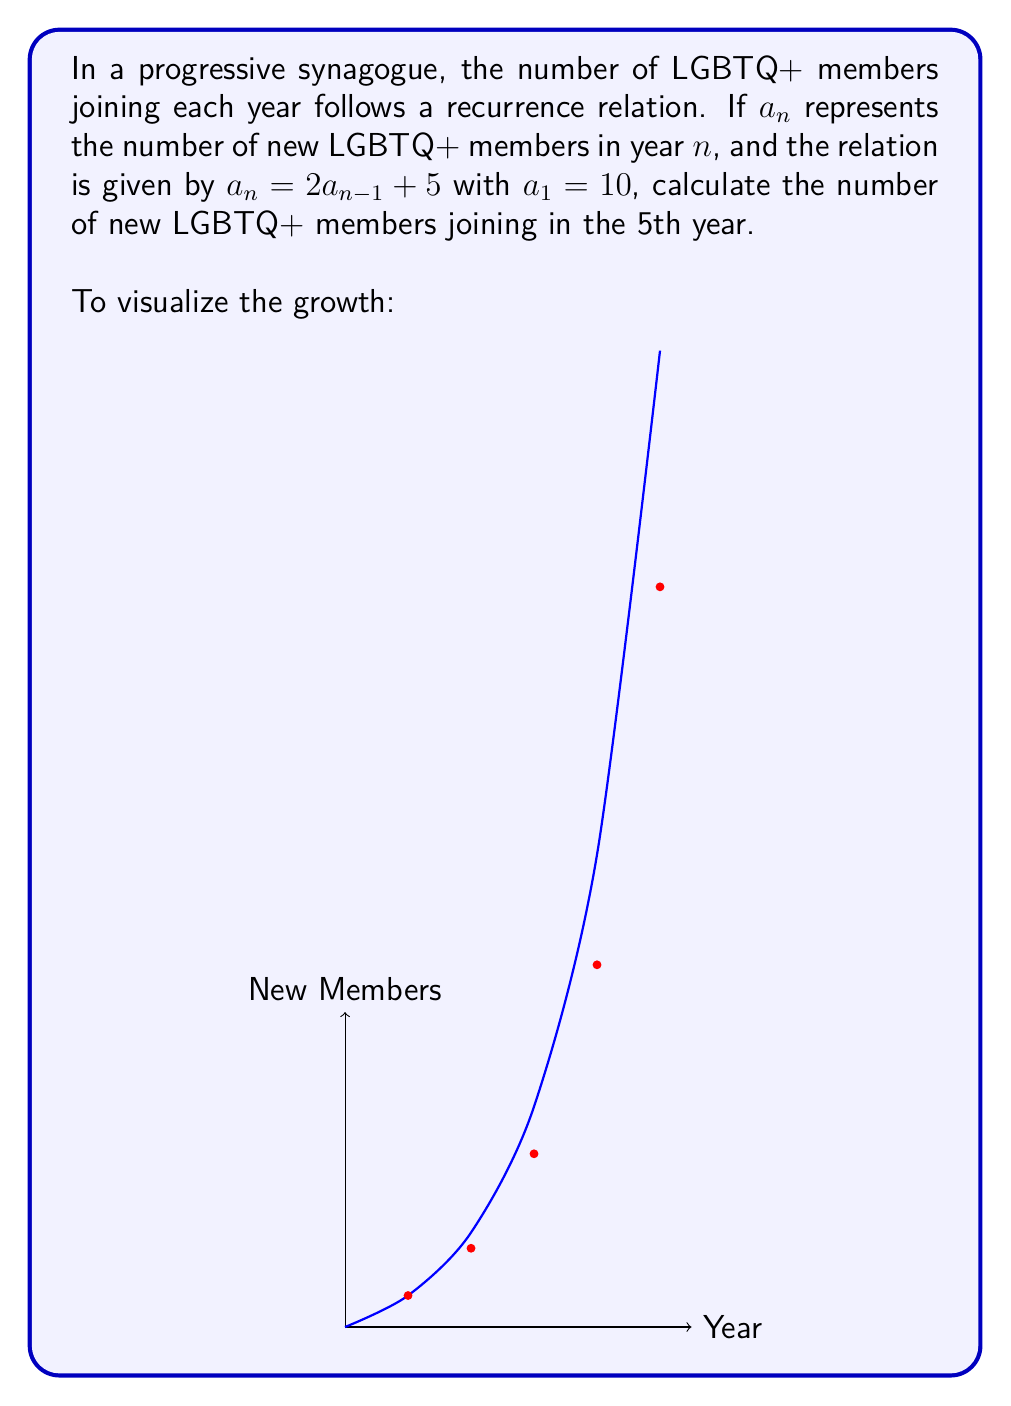What is the answer to this math problem? Let's solve this step-by-step:

1) We're given the recurrence relation: $a_n = 2a_{n-1} + 5$ with $a_1 = 10$

2) Let's calculate the first few terms:
   $a_1 = 10$ (given)
   $a_2 = 2(10) + 5 = 25$
   $a_3 = 2(25) + 5 = 55$
   $a_4 = 2(55) + 5 = 115$

3) For $a_5$, we use the same relation:
   $a_5 = 2a_4 + 5$
   $a_5 = 2(115) + 5$
   $a_5 = 230 + 5 = 235$

4) We can verify this matches the general solution for this recurrence relation:
   $a_n = 5(2^n - 1)$
   $a_5 = 5(2^5 - 1) = 5(32 - 1) = 5(31) = 155$

Therefore, in the 5th year, 235 new LGBTQ+ members will join the synagogue.
Answer: 235 